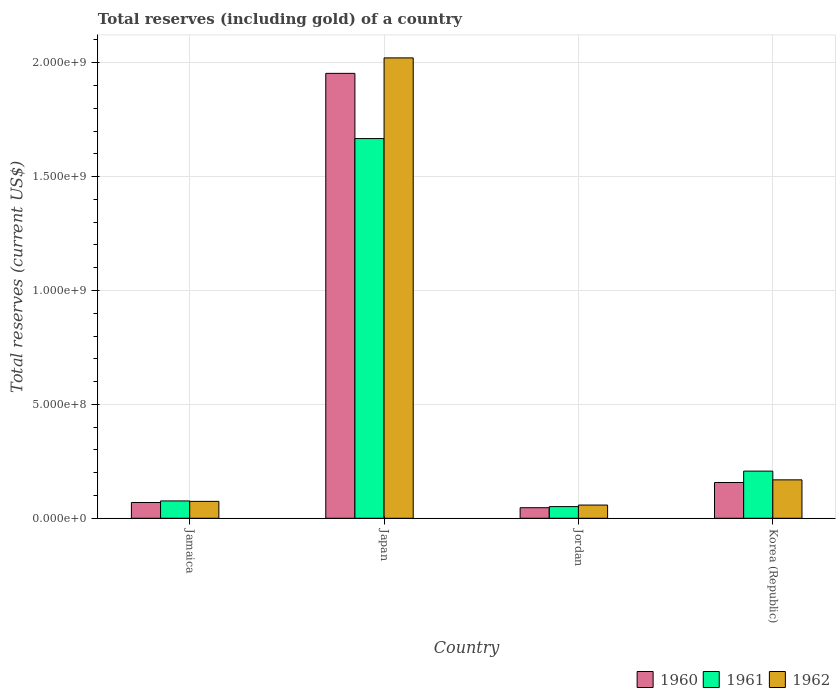How many bars are there on the 3rd tick from the left?
Provide a succinct answer. 3. What is the label of the 3rd group of bars from the left?
Keep it short and to the point. Jordan. What is the total reserves (including gold) in 1961 in Japan?
Keep it short and to the point. 1.67e+09. Across all countries, what is the maximum total reserves (including gold) in 1961?
Give a very brief answer. 1.67e+09. Across all countries, what is the minimum total reserves (including gold) in 1960?
Give a very brief answer. 4.64e+07. In which country was the total reserves (including gold) in 1962 minimum?
Offer a terse response. Jordan. What is the total total reserves (including gold) in 1960 in the graph?
Your response must be concise. 2.23e+09. What is the difference between the total reserves (including gold) in 1960 in Jamaica and that in Japan?
Your answer should be very brief. -1.88e+09. What is the difference between the total reserves (including gold) in 1962 in Japan and the total reserves (including gold) in 1960 in Jordan?
Provide a succinct answer. 1.97e+09. What is the average total reserves (including gold) in 1962 per country?
Keep it short and to the point. 5.81e+08. What is the difference between the total reserves (including gold) of/in 1961 and total reserves (including gold) of/in 1960 in Korea (Republic)?
Offer a terse response. 5.00e+07. In how many countries, is the total reserves (including gold) in 1960 greater than 1900000000 US$?
Provide a succinct answer. 1. What is the ratio of the total reserves (including gold) in 1961 in Japan to that in Korea (Republic)?
Your answer should be very brief. 8.05. Is the total reserves (including gold) in 1961 in Jamaica less than that in Jordan?
Offer a terse response. No. Is the difference between the total reserves (including gold) in 1961 in Japan and Korea (Republic) greater than the difference between the total reserves (including gold) in 1960 in Japan and Korea (Republic)?
Keep it short and to the point. No. What is the difference between the highest and the second highest total reserves (including gold) in 1962?
Your answer should be compact. -1.95e+09. What is the difference between the highest and the lowest total reserves (including gold) in 1961?
Provide a short and direct response. 1.62e+09. In how many countries, is the total reserves (including gold) in 1961 greater than the average total reserves (including gold) in 1961 taken over all countries?
Offer a very short reply. 1. Is the sum of the total reserves (including gold) in 1960 in Jordan and Korea (Republic) greater than the maximum total reserves (including gold) in 1962 across all countries?
Your answer should be very brief. No. What does the 1st bar from the left in Korea (Republic) represents?
Provide a short and direct response. 1960. Are all the bars in the graph horizontal?
Ensure brevity in your answer.  No. How many countries are there in the graph?
Your response must be concise. 4. What is the difference between two consecutive major ticks on the Y-axis?
Offer a terse response. 5.00e+08. Are the values on the major ticks of Y-axis written in scientific E-notation?
Your response must be concise. Yes. Where does the legend appear in the graph?
Offer a terse response. Bottom right. How many legend labels are there?
Your response must be concise. 3. What is the title of the graph?
Keep it short and to the point. Total reserves (including gold) of a country. What is the label or title of the Y-axis?
Your answer should be compact. Total reserves (current US$). What is the Total reserves (current US$) in 1960 in Jamaica?
Keep it short and to the point. 6.92e+07. What is the Total reserves (current US$) in 1961 in Jamaica?
Ensure brevity in your answer.  7.61e+07. What is the Total reserves (current US$) of 1962 in Jamaica?
Your response must be concise. 7.42e+07. What is the Total reserves (current US$) of 1960 in Japan?
Your answer should be very brief. 1.95e+09. What is the Total reserves (current US$) in 1961 in Japan?
Your response must be concise. 1.67e+09. What is the Total reserves (current US$) in 1962 in Japan?
Your response must be concise. 2.02e+09. What is the Total reserves (current US$) of 1960 in Jordan?
Your response must be concise. 4.64e+07. What is the Total reserves (current US$) in 1961 in Jordan?
Keep it short and to the point. 5.12e+07. What is the Total reserves (current US$) in 1962 in Jordan?
Your response must be concise. 5.80e+07. What is the Total reserves (current US$) of 1960 in Korea (Republic)?
Your answer should be very brief. 1.57e+08. What is the Total reserves (current US$) in 1961 in Korea (Republic)?
Your response must be concise. 2.07e+08. What is the Total reserves (current US$) of 1962 in Korea (Republic)?
Give a very brief answer. 1.69e+08. Across all countries, what is the maximum Total reserves (current US$) of 1960?
Ensure brevity in your answer.  1.95e+09. Across all countries, what is the maximum Total reserves (current US$) of 1961?
Your answer should be very brief. 1.67e+09. Across all countries, what is the maximum Total reserves (current US$) of 1962?
Your answer should be compact. 2.02e+09. Across all countries, what is the minimum Total reserves (current US$) of 1960?
Ensure brevity in your answer.  4.64e+07. Across all countries, what is the minimum Total reserves (current US$) in 1961?
Give a very brief answer. 5.12e+07. Across all countries, what is the minimum Total reserves (current US$) of 1962?
Your answer should be very brief. 5.80e+07. What is the total Total reserves (current US$) of 1960 in the graph?
Keep it short and to the point. 2.23e+09. What is the total Total reserves (current US$) in 1961 in the graph?
Offer a very short reply. 2.00e+09. What is the total Total reserves (current US$) in 1962 in the graph?
Give a very brief answer. 2.32e+09. What is the difference between the Total reserves (current US$) of 1960 in Jamaica and that in Japan?
Your answer should be compact. -1.88e+09. What is the difference between the Total reserves (current US$) of 1961 in Jamaica and that in Japan?
Your answer should be compact. -1.59e+09. What is the difference between the Total reserves (current US$) in 1962 in Jamaica and that in Japan?
Keep it short and to the point. -1.95e+09. What is the difference between the Total reserves (current US$) of 1960 in Jamaica and that in Jordan?
Make the answer very short. 2.28e+07. What is the difference between the Total reserves (current US$) in 1961 in Jamaica and that in Jordan?
Offer a very short reply. 2.49e+07. What is the difference between the Total reserves (current US$) of 1962 in Jamaica and that in Jordan?
Give a very brief answer. 1.62e+07. What is the difference between the Total reserves (current US$) in 1960 in Jamaica and that in Korea (Republic)?
Offer a terse response. -8.78e+07. What is the difference between the Total reserves (current US$) in 1961 in Jamaica and that in Korea (Republic)?
Offer a terse response. -1.31e+08. What is the difference between the Total reserves (current US$) in 1962 in Jamaica and that in Korea (Republic)?
Your response must be concise. -9.45e+07. What is the difference between the Total reserves (current US$) in 1960 in Japan and that in Jordan?
Your answer should be very brief. 1.91e+09. What is the difference between the Total reserves (current US$) in 1961 in Japan and that in Jordan?
Keep it short and to the point. 1.62e+09. What is the difference between the Total reserves (current US$) of 1962 in Japan and that in Jordan?
Ensure brevity in your answer.  1.96e+09. What is the difference between the Total reserves (current US$) of 1960 in Japan and that in Korea (Republic)?
Provide a succinct answer. 1.80e+09. What is the difference between the Total reserves (current US$) of 1961 in Japan and that in Korea (Republic)?
Your answer should be compact. 1.46e+09. What is the difference between the Total reserves (current US$) of 1962 in Japan and that in Korea (Republic)?
Keep it short and to the point. 1.85e+09. What is the difference between the Total reserves (current US$) in 1960 in Jordan and that in Korea (Republic)?
Offer a terse response. -1.11e+08. What is the difference between the Total reserves (current US$) in 1961 in Jordan and that in Korea (Republic)?
Give a very brief answer. -1.56e+08. What is the difference between the Total reserves (current US$) of 1962 in Jordan and that in Korea (Republic)?
Your answer should be compact. -1.11e+08. What is the difference between the Total reserves (current US$) in 1960 in Jamaica and the Total reserves (current US$) in 1961 in Japan?
Offer a terse response. -1.60e+09. What is the difference between the Total reserves (current US$) of 1960 in Jamaica and the Total reserves (current US$) of 1962 in Japan?
Your answer should be compact. -1.95e+09. What is the difference between the Total reserves (current US$) of 1961 in Jamaica and the Total reserves (current US$) of 1962 in Japan?
Offer a terse response. -1.95e+09. What is the difference between the Total reserves (current US$) of 1960 in Jamaica and the Total reserves (current US$) of 1961 in Jordan?
Give a very brief answer. 1.80e+07. What is the difference between the Total reserves (current US$) of 1960 in Jamaica and the Total reserves (current US$) of 1962 in Jordan?
Provide a succinct answer. 1.12e+07. What is the difference between the Total reserves (current US$) of 1961 in Jamaica and the Total reserves (current US$) of 1962 in Jordan?
Provide a succinct answer. 1.81e+07. What is the difference between the Total reserves (current US$) in 1960 in Jamaica and the Total reserves (current US$) in 1961 in Korea (Republic)?
Provide a short and direct response. -1.38e+08. What is the difference between the Total reserves (current US$) in 1960 in Jamaica and the Total reserves (current US$) in 1962 in Korea (Republic)?
Your response must be concise. -9.95e+07. What is the difference between the Total reserves (current US$) of 1961 in Jamaica and the Total reserves (current US$) of 1962 in Korea (Republic)?
Keep it short and to the point. -9.26e+07. What is the difference between the Total reserves (current US$) in 1960 in Japan and the Total reserves (current US$) in 1961 in Jordan?
Your answer should be compact. 1.90e+09. What is the difference between the Total reserves (current US$) of 1960 in Japan and the Total reserves (current US$) of 1962 in Jordan?
Provide a short and direct response. 1.90e+09. What is the difference between the Total reserves (current US$) of 1961 in Japan and the Total reserves (current US$) of 1962 in Jordan?
Ensure brevity in your answer.  1.61e+09. What is the difference between the Total reserves (current US$) of 1960 in Japan and the Total reserves (current US$) of 1961 in Korea (Republic)?
Provide a succinct answer. 1.75e+09. What is the difference between the Total reserves (current US$) in 1960 in Japan and the Total reserves (current US$) in 1962 in Korea (Republic)?
Provide a succinct answer. 1.78e+09. What is the difference between the Total reserves (current US$) in 1961 in Japan and the Total reserves (current US$) in 1962 in Korea (Republic)?
Your response must be concise. 1.50e+09. What is the difference between the Total reserves (current US$) in 1960 in Jordan and the Total reserves (current US$) in 1961 in Korea (Republic)?
Offer a terse response. -1.61e+08. What is the difference between the Total reserves (current US$) of 1960 in Jordan and the Total reserves (current US$) of 1962 in Korea (Republic)?
Make the answer very short. -1.22e+08. What is the difference between the Total reserves (current US$) in 1961 in Jordan and the Total reserves (current US$) in 1962 in Korea (Republic)?
Ensure brevity in your answer.  -1.17e+08. What is the average Total reserves (current US$) of 1960 per country?
Ensure brevity in your answer.  5.56e+08. What is the average Total reserves (current US$) in 1961 per country?
Keep it short and to the point. 5.00e+08. What is the average Total reserves (current US$) in 1962 per country?
Your response must be concise. 5.81e+08. What is the difference between the Total reserves (current US$) in 1960 and Total reserves (current US$) in 1961 in Jamaica?
Your response must be concise. -6.90e+06. What is the difference between the Total reserves (current US$) in 1960 and Total reserves (current US$) in 1962 in Jamaica?
Offer a very short reply. -5.00e+06. What is the difference between the Total reserves (current US$) of 1961 and Total reserves (current US$) of 1962 in Jamaica?
Your response must be concise. 1.90e+06. What is the difference between the Total reserves (current US$) in 1960 and Total reserves (current US$) in 1961 in Japan?
Your answer should be compact. 2.86e+08. What is the difference between the Total reserves (current US$) in 1960 and Total reserves (current US$) in 1962 in Japan?
Give a very brief answer. -6.80e+07. What is the difference between the Total reserves (current US$) in 1961 and Total reserves (current US$) in 1962 in Japan?
Your answer should be very brief. -3.54e+08. What is the difference between the Total reserves (current US$) in 1960 and Total reserves (current US$) in 1961 in Jordan?
Your answer should be compact. -4.85e+06. What is the difference between the Total reserves (current US$) of 1960 and Total reserves (current US$) of 1962 in Jordan?
Provide a short and direct response. -1.17e+07. What is the difference between the Total reserves (current US$) of 1961 and Total reserves (current US$) of 1962 in Jordan?
Make the answer very short. -6.82e+06. What is the difference between the Total reserves (current US$) of 1960 and Total reserves (current US$) of 1961 in Korea (Republic)?
Provide a short and direct response. -5.00e+07. What is the difference between the Total reserves (current US$) in 1960 and Total reserves (current US$) in 1962 in Korea (Republic)?
Your answer should be very brief. -1.16e+07. What is the difference between the Total reserves (current US$) in 1961 and Total reserves (current US$) in 1962 in Korea (Republic)?
Provide a short and direct response. 3.84e+07. What is the ratio of the Total reserves (current US$) of 1960 in Jamaica to that in Japan?
Your answer should be very brief. 0.04. What is the ratio of the Total reserves (current US$) of 1961 in Jamaica to that in Japan?
Make the answer very short. 0.05. What is the ratio of the Total reserves (current US$) in 1962 in Jamaica to that in Japan?
Your response must be concise. 0.04. What is the ratio of the Total reserves (current US$) in 1960 in Jamaica to that in Jordan?
Provide a short and direct response. 1.49. What is the ratio of the Total reserves (current US$) of 1961 in Jamaica to that in Jordan?
Ensure brevity in your answer.  1.49. What is the ratio of the Total reserves (current US$) in 1962 in Jamaica to that in Jordan?
Offer a very short reply. 1.28. What is the ratio of the Total reserves (current US$) of 1960 in Jamaica to that in Korea (Republic)?
Offer a terse response. 0.44. What is the ratio of the Total reserves (current US$) in 1961 in Jamaica to that in Korea (Republic)?
Give a very brief answer. 0.37. What is the ratio of the Total reserves (current US$) in 1962 in Jamaica to that in Korea (Republic)?
Offer a terse response. 0.44. What is the ratio of the Total reserves (current US$) in 1960 in Japan to that in Jordan?
Provide a succinct answer. 42.12. What is the ratio of the Total reserves (current US$) of 1961 in Japan to that in Jordan?
Offer a very short reply. 32.54. What is the ratio of the Total reserves (current US$) in 1962 in Japan to that in Jordan?
Provide a short and direct response. 34.82. What is the ratio of the Total reserves (current US$) of 1960 in Japan to that in Korea (Republic)?
Give a very brief answer. 12.44. What is the ratio of the Total reserves (current US$) of 1961 in Japan to that in Korea (Republic)?
Make the answer very short. 8.05. What is the ratio of the Total reserves (current US$) of 1962 in Japan to that in Korea (Republic)?
Your response must be concise. 11.99. What is the ratio of the Total reserves (current US$) of 1960 in Jordan to that in Korea (Republic)?
Provide a succinct answer. 0.3. What is the ratio of the Total reserves (current US$) in 1961 in Jordan to that in Korea (Republic)?
Offer a terse response. 0.25. What is the ratio of the Total reserves (current US$) of 1962 in Jordan to that in Korea (Republic)?
Ensure brevity in your answer.  0.34. What is the difference between the highest and the second highest Total reserves (current US$) in 1960?
Your answer should be very brief. 1.80e+09. What is the difference between the highest and the second highest Total reserves (current US$) of 1961?
Keep it short and to the point. 1.46e+09. What is the difference between the highest and the second highest Total reserves (current US$) of 1962?
Keep it short and to the point. 1.85e+09. What is the difference between the highest and the lowest Total reserves (current US$) in 1960?
Offer a very short reply. 1.91e+09. What is the difference between the highest and the lowest Total reserves (current US$) in 1961?
Make the answer very short. 1.62e+09. What is the difference between the highest and the lowest Total reserves (current US$) of 1962?
Provide a succinct answer. 1.96e+09. 